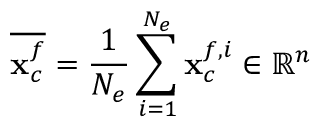<formula> <loc_0><loc_0><loc_500><loc_500>\overline { { { x } _ { c } ^ { f } } } = \frac { 1 } { N _ { e } } \sum _ { \substack { i = 1 } } ^ { N _ { e } } { { x } _ { c } ^ { f , i } } \in \mathbb { R } ^ { n }</formula> 